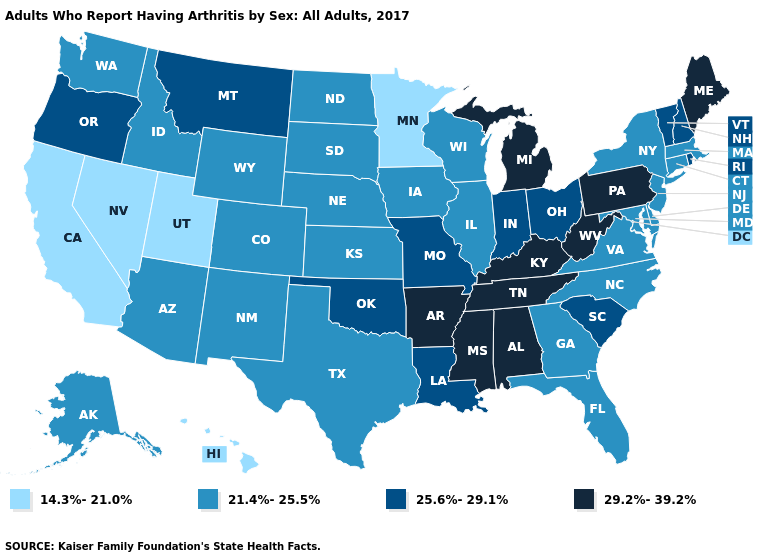Name the states that have a value in the range 25.6%-29.1%?
Quick response, please. Indiana, Louisiana, Missouri, Montana, New Hampshire, Ohio, Oklahoma, Oregon, Rhode Island, South Carolina, Vermont. What is the value of Wyoming?
Give a very brief answer. 21.4%-25.5%. Does California have the lowest value in the West?
Answer briefly. Yes. Does the map have missing data?
Give a very brief answer. No. Name the states that have a value in the range 21.4%-25.5%?
Short answer required. Alaska, Arizona, Colorado, Connecticut, Delaware, Florida, Georgia, Idaho, Illinois, Iowa, Kansas, Maryland, Massachusetts, Nebraska, New Jersey, New Mexico, New York, North Carolina, North Dakota, South Dakota, Texas, Virginia, Washington, Wisconsin, Wyoming. Name the states that have a value in the range 21.4%-25.5%?
Quick response, please. Alaska, Arizona, Colorado, Connecticut, Delaware, Florida, Georgia, Idaho, Illinois, Iowa, Kansas, Maryland, Massachusetts, Nebraska, New Jersey, New Mexico, New York, North Carolina, North Dakota, South Dakota, Texas, Virginia, Washington, Wisconsin, Wyoming. What is the value of Mississippi?
Keep it brief. 29.2%-39.2%. Name the states that have a value in the range 21.4%-25.5%?
Quick response, please. Alaska, Arizona, Colorado, Connecticut, Delaware, Florida, Georgia, Idaho, Illinois, Iowa, Kansas, Maryland, Massachusetts, Nebraska, New Jersey, New Mexico, New York, North Carolina, North Dakota, South Dakota, Texas, Virginia, Washington, Wisconsin, Wyoming. Which states have the lowest value in the West?
Write a very short answer. California, Hawaii, Nevada, Utah. What is the value of Wyoming?
Concise answer only. 21.4%-25.5%. What is the value of Nebraska?
Be succinct. 21.4%-25.5%. What is the lowest value in the MidWest?
Give a very brief answer. 14.3%-21.0%. Does Oklahoma have the highest value in the South?
Give a very brief answer. No. What is the value of Arizona?
Keep it brief. 21.4%-25.5%. What is the value of Connecticut?
Answer briefly. 21.4%-25.5%. 